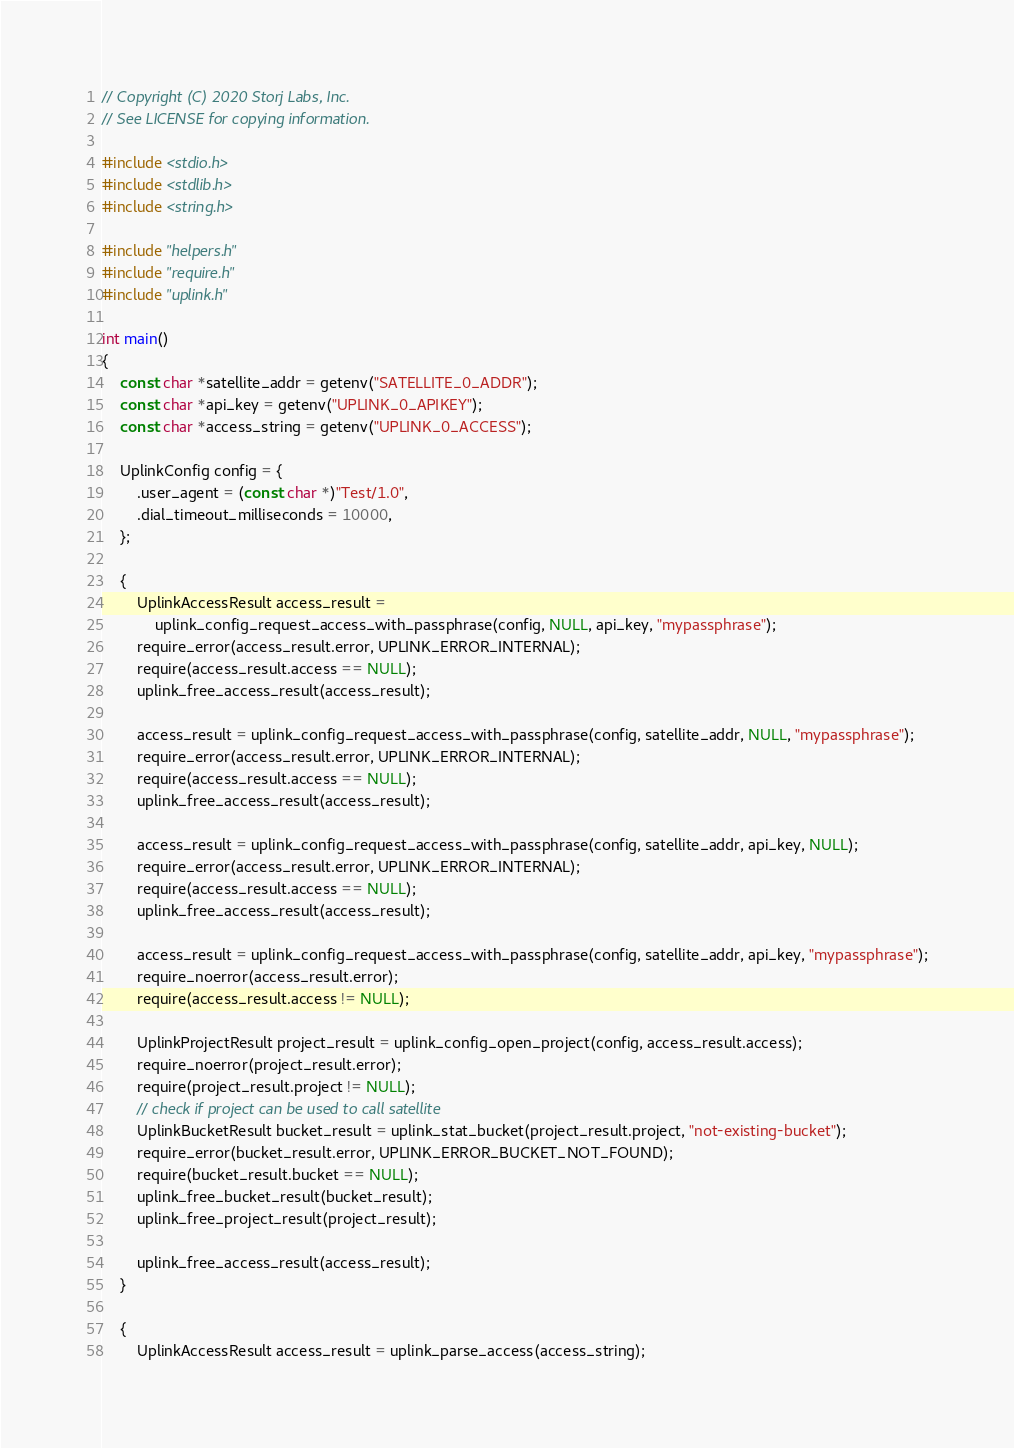<code> <loc_0><loc_0><loc_500><loc_500><_C_>// Copyright (C) 2020 Storj Labs, Inc.
// See LICENSE for copying information.

#include <stdio.h>
#include <stdlib.h>
#include <string.h>

#include "helpers.h"
#include "require.h"
#include "uplink.h"

int main()
{
    const char *satellite_addr = getenv("SATELLITE_0_ADDR");
    const char *api_key = getenv("UPLINK_0_APIKEY");
    const char *access_string = getenv("UPLINK_0_ACCESS");

    UplinkConfig config = {
        .user_agent = (const char *)"Test/1.0",
        .dial_timeout_milliseconds = 10000,
    };

    {
        UplinkAccessResult access_result =
            uplink_config_request_access_with_passphrase(config, NULL, api_key, "mypassphrase");
        require_error(access_result.error, UPLINK_ERROR_INTERNAL);
        require(access_result.access == NULL);
        uplink_free_access_result(access_result);

        access_result = uplink_config_request_access_with_passphrase(config, satellite_addr, NULL, "mypassphrase");
        require_error(access_result.error, UPLINK_ERROR_INTERNAL);
        require(access_result.access == NULL);
        uplink_free_access_result(access_result);

        access_result = uplink_config_request_access_with_passphrase(config, satellite_addr, api_key, NULL);
        require_error(access_result.error, UPLINK_ERROR_INTERNAL);
        require(access_result.access == NULL);
        uplink_free_access_result(access_result);

        access_result = uplink_config_request_access_with_passphrase(config, satellite_addr, api_key, "mypassphrase");
        require_noerror(access_result.error);
        require(access_result.access != NULL);

        UplinkProjectResult project_result = uplink_config_open_project(config, access_result.access);
        require_noerror(project_result.error);
        require(project_result.project != NULL);
        // check if project can be used to call satellite
        UplinkBucketResult bucket_result = uplink_stat_bucket(project_result.project, "not-existing-bucket");
        require_error(bucket_result.error, UPLINK_ERROR_BUCKET_NOT_FOUND);
        require(bucket_result.bucket == NULL);
        uplink_free_bucket_result(bucket_result);
        uplink_free_project_result(project_result);

        uplink_free_access_result(access_result);
    }

    {
        UplinkAccessResult access_result = uplink_parse_access(access_string);</code> 